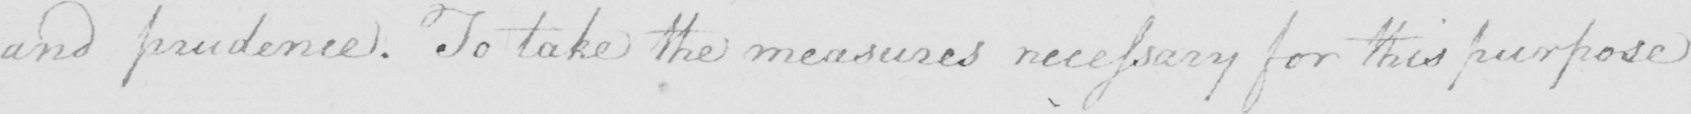Please transcribe the handwritten text in this image. and prudence . To take the measures necessary for this purpose 